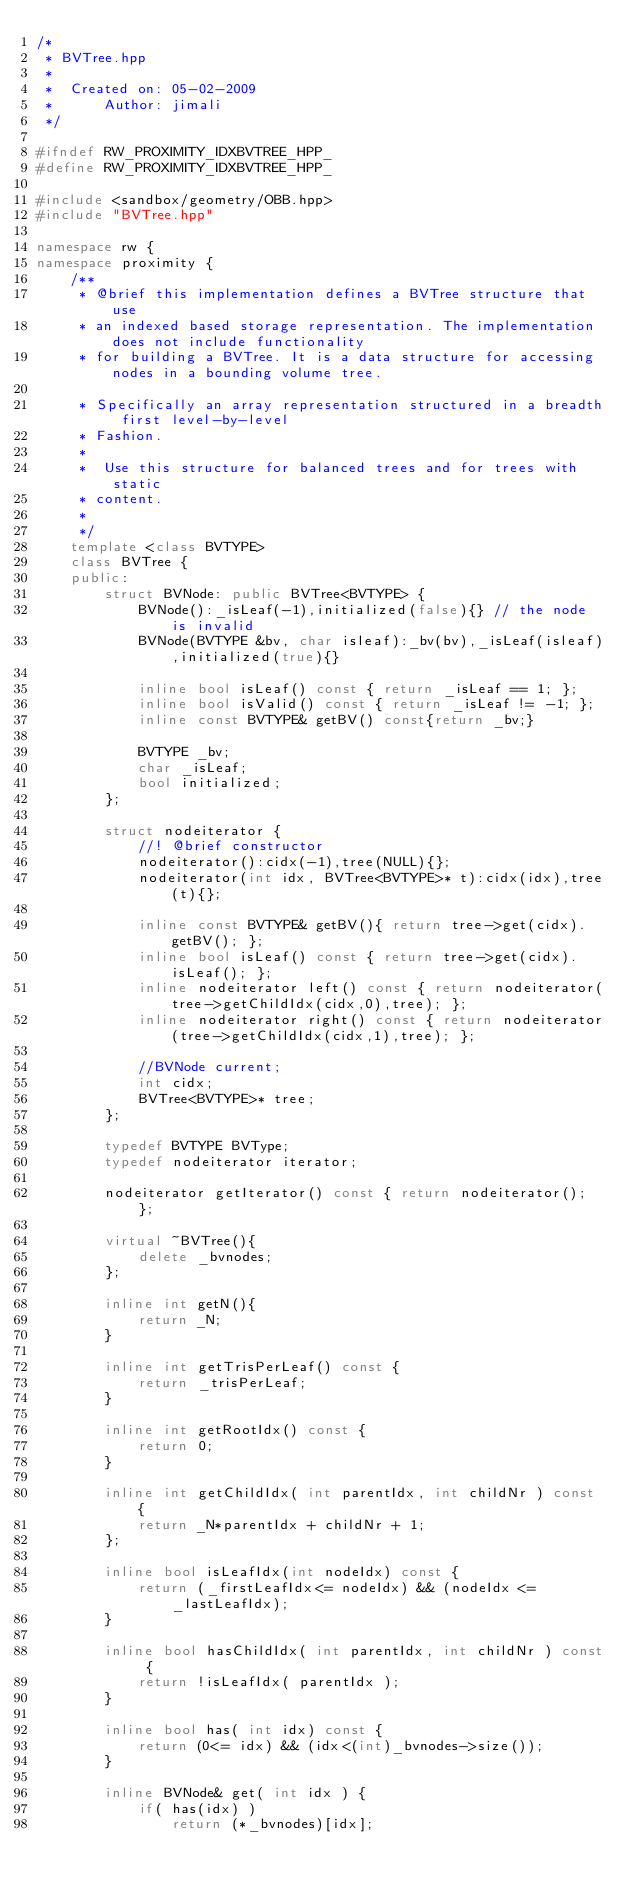<code> <loc_0><loc_0><loc_500><loc_500><_C++_>/*
 * BVTree.hpp
 *
 *  Created on: 05-02-2009
 *      Author: jimali
 */

#ifndef RW_PROXIMITY_IDXBVTREE_HPP_
#define RW_PROXIMITY_IDXBVTREE_HPP_

#include <sandbox/geometry/OBB.hpp>
#include "BVTree.hpp"

namespace rw {
namespace proximity {
	/**
	 * @brief this implementation defines a BVTree structure that use
	 * an indexed based storage representation. The implementation does not include functionality
	 * for building a BVTree. It is a data structure for accessing nodes in a bounding volume tree.

	 * Specifically an array representation structured in a breadth first level-by-level
	 * Fashion.
	 *
	 *  Use this structure for balanced trees and for trees with static
	 * content.
	 *
	 */
	template <class BVTYPE>
	class BVTree {
	public:
		struct BVNode: public BVTree<BVTYPE> {
			BVNode():_isLeaf(-1),initialized(false){} // the node is invalid
			BVNode(BVTYPE &bv, char isleaf):_bv(bv),_isLeaf(isleaf),initialized(true){}

			inline bool isLeaf() const { return _isLeaf == 1; };
			inline bool isValid() const { return _isLeaf != -1; };
			inline const BVTYPE& getBV() const{return _bv;}

			BVTYPE _bv;
			char _isLeaf;
			bool initialized;
		};

		struct nodeiterator {
			//! @brief constructor
			nodeiterator():cidx(-1),tree(NULL){};
			nodeiterator(int idx, BVTree<BVTYPE>* t):cidx(idx),tree(t){};

			inline const BVTYPE& getBV(){ return tree->get(cidx).getBV(); };
			inline bool isLeaf() const { return tree->get(cidx).isLeaf(); };
			inline nodeiterator left() const { return nodeiterator(tree->getChildIdx(cidx,0),tree); };
			inline nodeiterator right() const { return nodeiterator(tree->getChildIdx(cidx,1),tree); };

			//BVNode current;
			int cidx;
			BVTree<BVTYPE>* tree;
		};

		typedef BVTYPE BVType;
		typedef nodeiterator iterator;

		nodeiterator getIterator() const { return nodeiterator(); };

		virtual ~BVTree(){
			delete _bvnodes;
		};

		inline int getN(){
			return _N;
		}

		inline int getTrisPerLeaf() const {
			return _trisPerLeaf;
		}

		inline int getRootIdx() const {
			return 0;
		}

		inline int getChildIdx( int parentIdx, int childNr ) const {
			return _N*parentIdx + childNr + 1;
		};

		inline bool isLeafIdx(int nodeIdx) const {
			return (_firstLeafIdx<= nodeIdx) && (nodeIdx <=_lastLeafIdx);
		}

		inline bool hasChildIdx( int parentIdx, int childNr ) const {
			return !isLeafIdx( parentIdx );
		}

		inline bool has( int idx) const {
			return (0<= idx) && (idx<(int)_bvnodes->size());
		}

		inline BVNode& get( int idx ) {
			if( has(idx) )
				return (*_bvnodes)[idx];</code> 